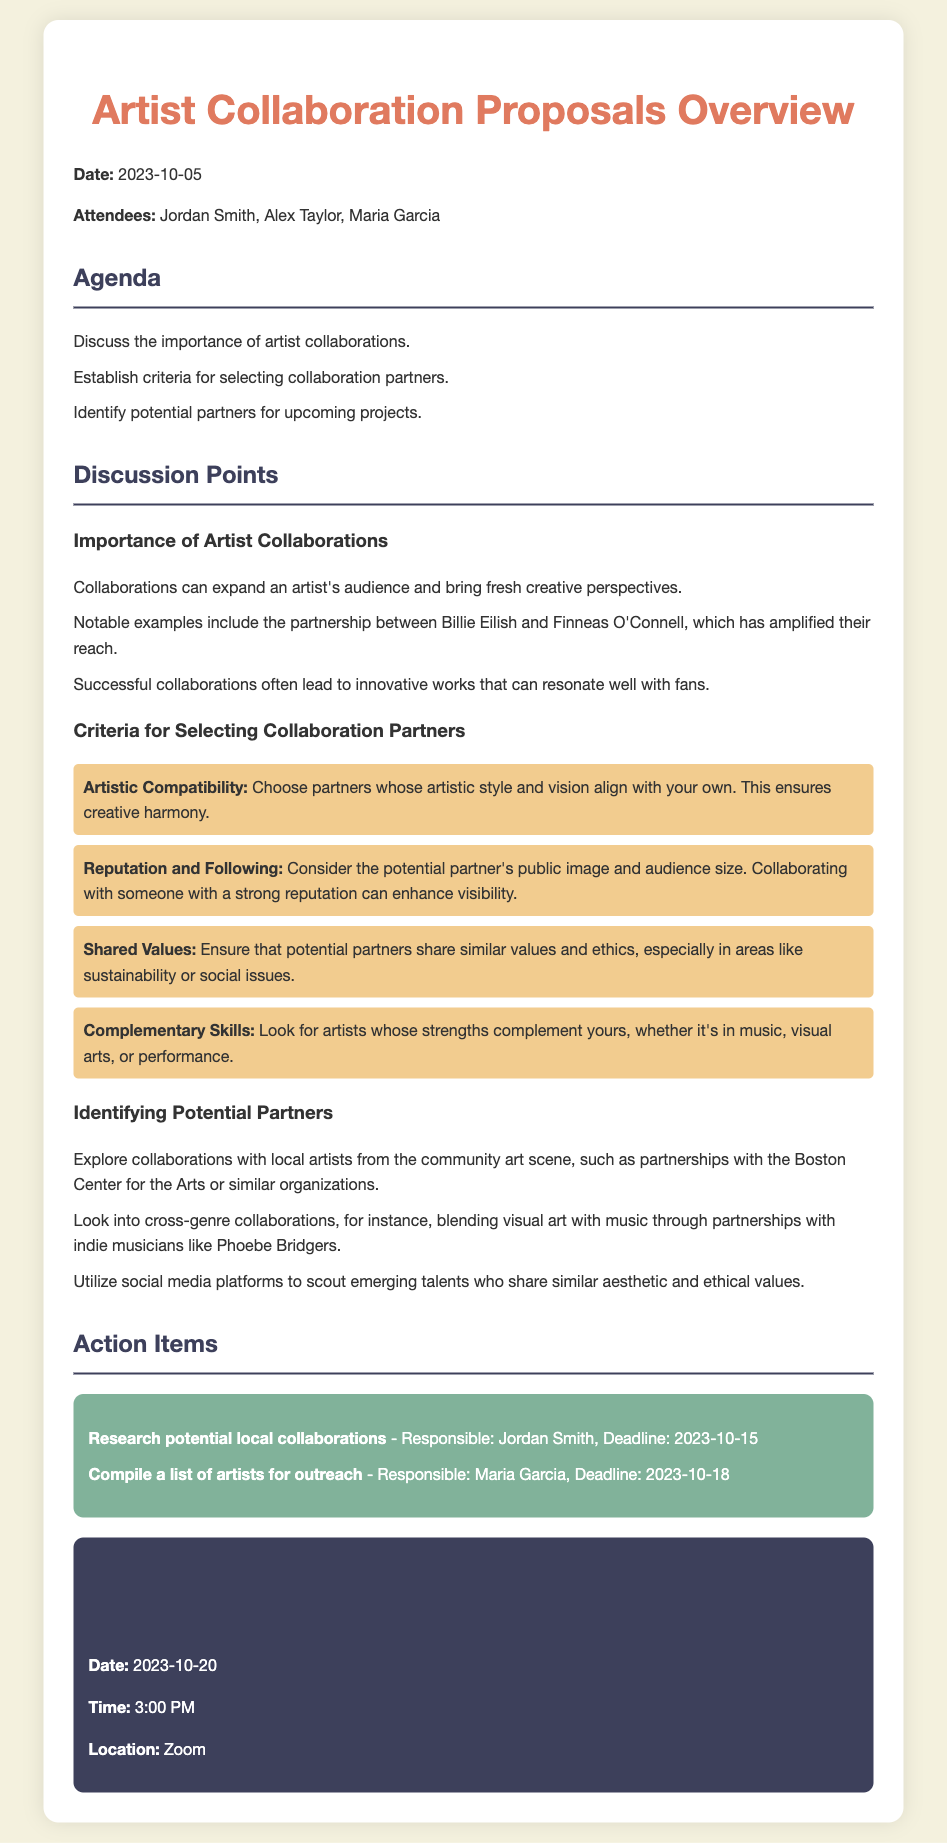What is the date of the meeting? The document specifies the meeting date as October 5, 2023.
Answer: October 5, 2023 Who are the attendees of the meeting? The document lists the attendees as Jordan Smith, Alex Taylor, and Maria Garcia.
Answer: Jordan Smith, Alex Taylor, Maria Garcia What is one notable example of artist collaboration mentioned? The document refers to the partnership between Billie Eilish and Finneas O'Connell as a notable example of collaboration.
Answer: Billie Eilish and Finneas O'Connell How many criteria for selecting collaboration partners are listed? The document outlines four specific criteria for selecting partners.
Answer: Four What is the responsibility assigned to Jordan Smith? Jordan Smith is tasked with researching potential local collaborations, according to the action items listed in the document.
Answer: Research potential local collaborations What is one aspect to consider regarding the potential partner's reputation? The document highlights the potential partner's public image and audience size as important factors.
Answer: Public image and audience size What is the location of the next meeting? The document states that the next meeting will be held on Zoom.
Answer: Zoom What date is set for the next meeting? The document indicates the next meeting is scheduled for October 20, 2023.
Answer: October 20, 2023 